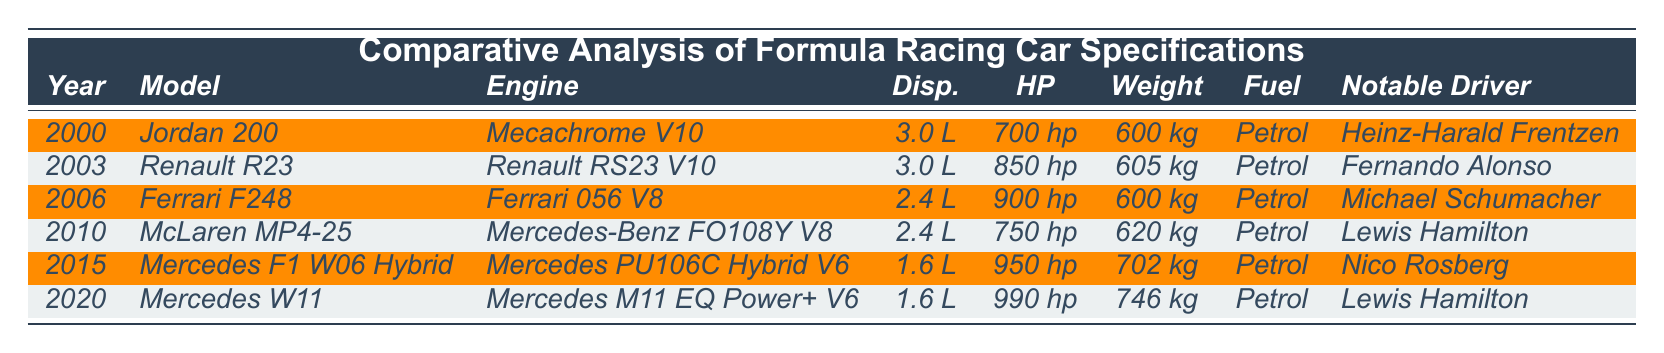What is the engine type of the 2003 car model? The table lists the engine type for each car model used in different years. For the 2003 model, which is the Renault R23, the engine type is specified as "Renault RS23 V10."
Answer: Renault RS23 V10 Which car had the highest horsepower? By comparing the horsepower values across all car models, the values are 700 hp, 850 hp, 900 hp, 750 hp, 950 hp, and 990 hp. The highest among them is 990 hp, which belongs to the 2020 model, Mercedes W11.
Answer: 990 hp Is there a car model with a weight below 600 kg? The table lists various weights for each car model, and all provided weights are 600 kg or more. Therefore, there is no car model weighing below 600 kg.
Answer: No What is the difference in horsepower between the 2006 and 2015 models? The horsepower for the 2006 model (Ferrari F248) is 900 hp and for the 2015 model (Mercedes F1 W06 Hybrid) it is 950 hp. Calculating the difference: 950 hp - 900 hp = 50 hp.
Answer: 50 hp What is the average weight of the cars listed in the table? The weights of the cars are 600 kg, 605 kg, 600 kg, 620 kg, 702 kg, and 746 kg. First, add them: 600 + 605 + 600 + 620 + 702 + 746 = 3873 kg. There are 6 cars, so the average weight is 3873 kg / 6 = 645.5 kg.
Answer: 645.5 kg Which year had a car model powered by a V6 engine? In the table, only the models from 2015 (Mercedes F1 W06 Hybrid) and 2020 (Mercedes W11) have V6 engines, indicated as "Mercedes PU106C Hybrid V6" and "Mercedes M11 EQ Power+ V6," respectively. The years mentioned are both 2015 and 2020.
Answer: 2015 and 2020 Which car had the lightest weight and what is that weight? By examining the weights of all car models, the lightest weight among them is 600 kg, which is shared by both the 2000 model (Jordan 200) and the 2006 model (Ferrari F248).
Answer: 600 kg Is it true that all car models used petrol? The table specifies that all listed models use "Petrol" as their fuel type, confirming that this statement is true across all entries.
Answer: Yes Which driver had the lowest horsepower car? The table indicates that the 2000 model (Jordan 200) has the lowest horsepower at 700 hp, and the notable driver for that car is Heinz-Harald Frentzen.
Answer: Heinz-Harald Frentzen How many years separate the models with the most and least horsepower? The model with the most horsepower is from 2020 with 990 hp (Mercedes W11), and the model with the least horsepower is from 2000 with 700 hp (Jordan 200). The years are 2020 and 2000, so the difference is 2020 - 2000 = 20 years.
Answer: 20 years 